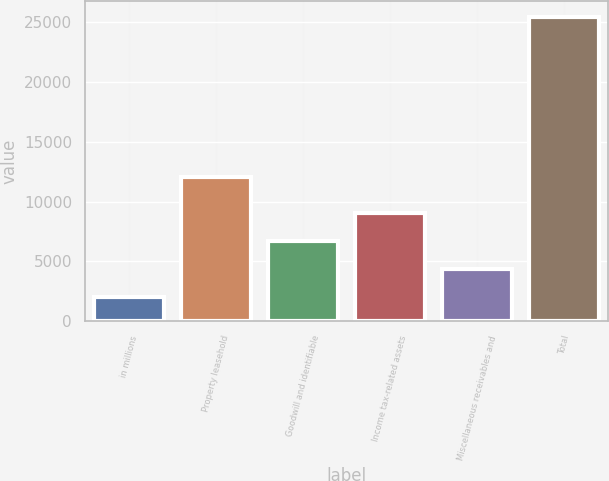Convert chart. <chart><loc_0><loc_0><loc_500><loc_500><bar_chart><fcel>in millions<fcel>Property leasehold<fcel>Goodwill and identifiable<fcel>Income tax-related assets<fcel>Miscellaneous receivables and<fcel>Total<nl><fcel>2016<fcel>12070<fcel>6709<fcel>9055.5<fcel>4362.5<fcel>25481<nl></chart> 